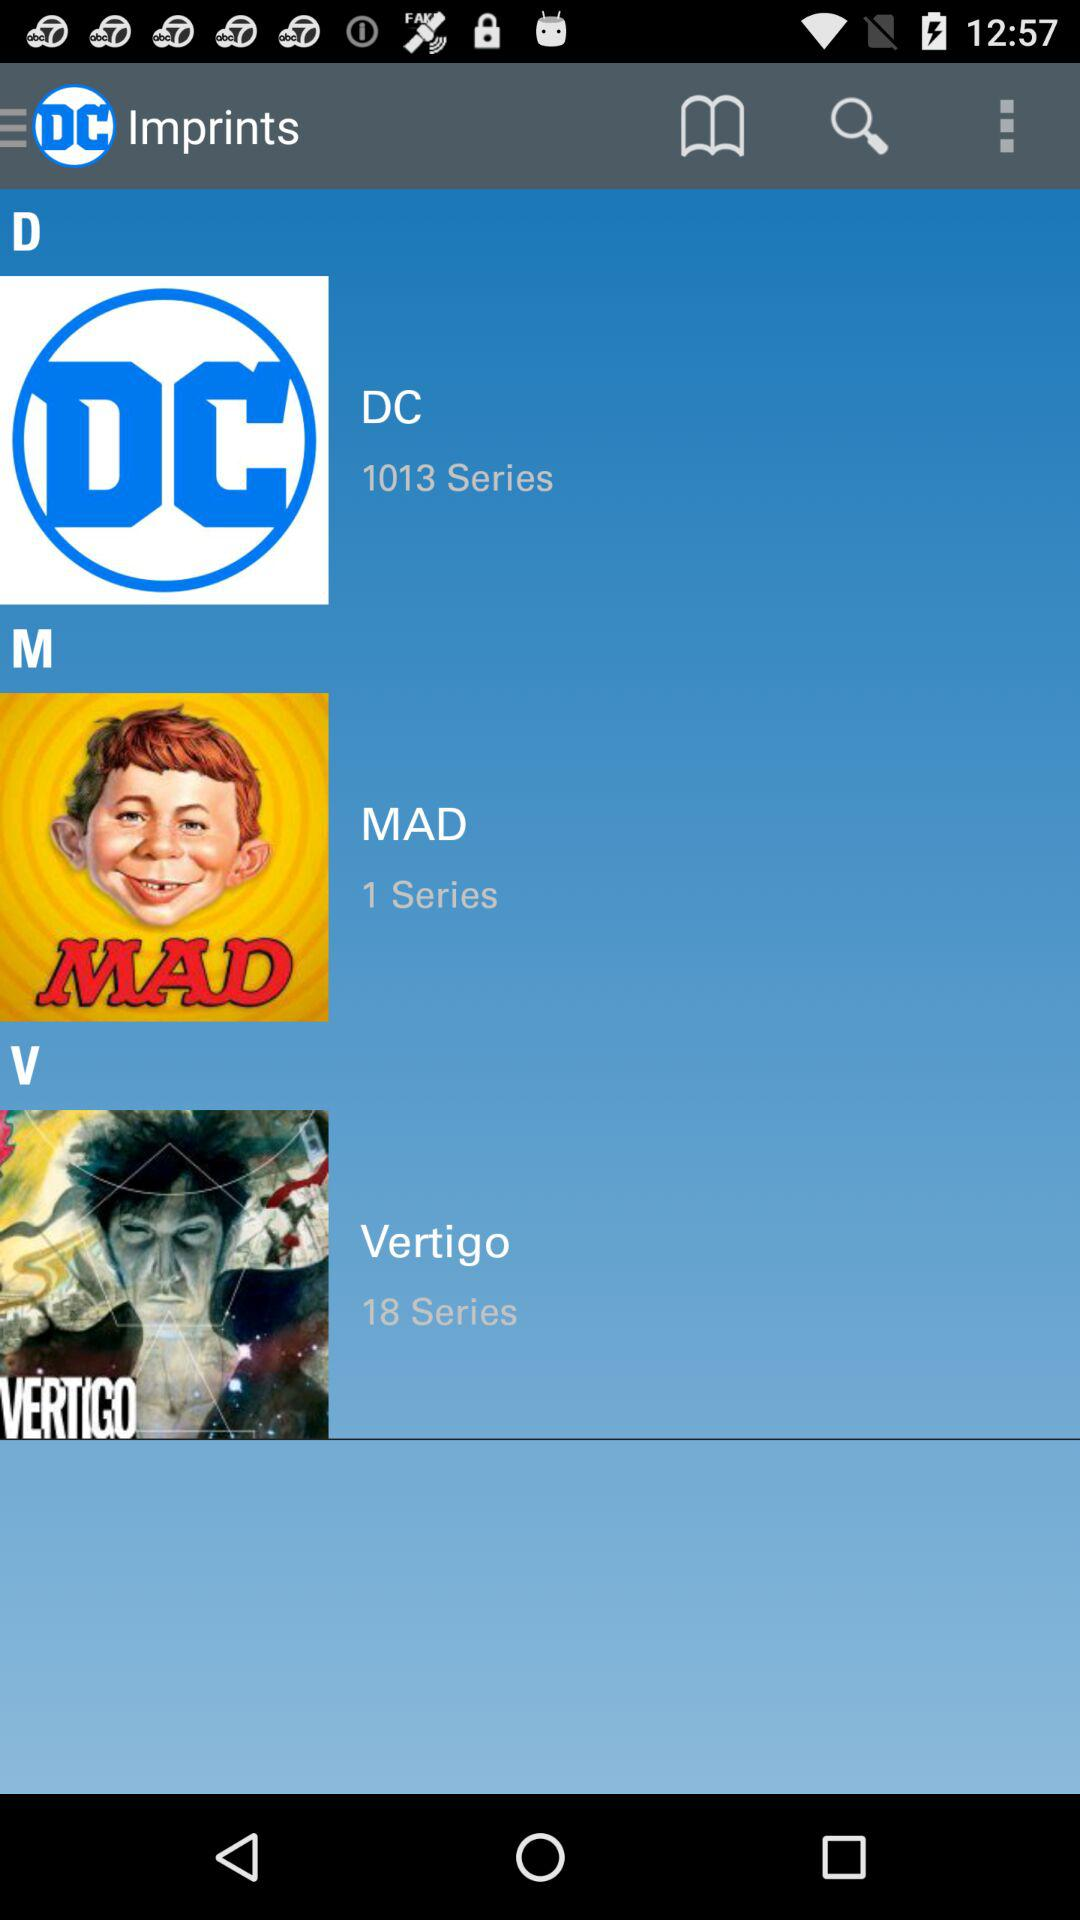How many series are there in "MAD"? There is 1 series in "MAD". 